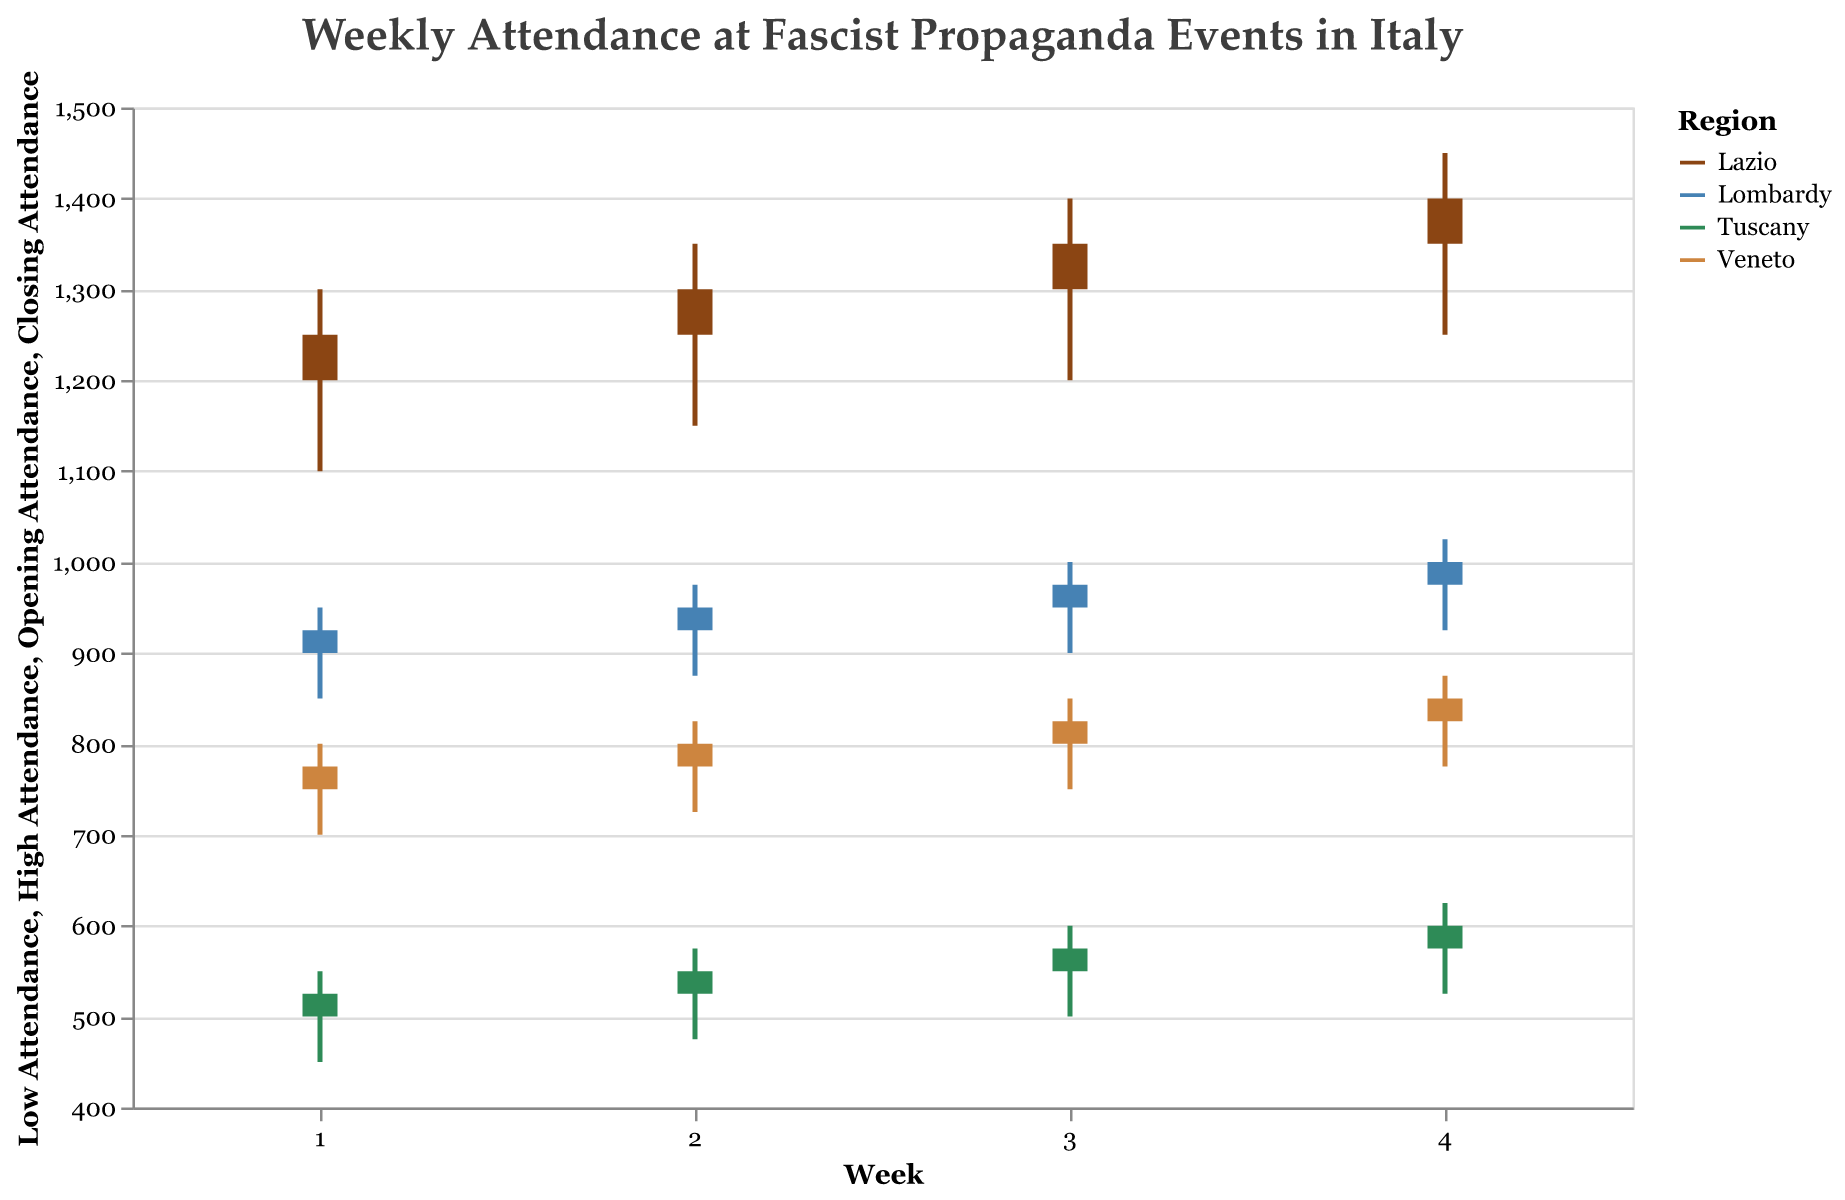What is the title of the figure? The title is usually displayed at the top of the figure and indicates the overall subject or data being presented.
Answer: Weekly Attendance at Fascist Propaganda Events in Italy Which region had the highest closing attendance in Week 4? Look for the closing attendance values for Week 4 across all regions and identify the highest one. For Week 4, closing attendance values are Lazio: 1400, Lombardy: 1000, Tuscany: 600, and Veneto: 850.
Answer: Lazio Across all regions, which week showed the most improvement in attendance from Opening to Closing? Calculate the difference between Opening and Closing attendance for each week and compare them.
Answer: Week 4 for Lazio (1400 - 1350 = 50) Identify the region with the least variability in attendance during Week 2. Variability can be understood by the range (High Attendance - Low Attendance). For Week 2, the ranges are Lazio: 1350 - 1150 = 200, Lombardy: 975 - 875 = 100, Tuscany: 575 - 475 = 100, Veneto: 825 - 725 = 100.
Answer: Lombardy, Tuscany, or Veneto Which region showed the most consistent week-to-week increase in attendance? Check if the increase (difference between closing attendance of consecutive weeks) is consistent for any region. Lazio shows a consistent increase from 1250, 1300, 1350, to 1400.
Answer: Lazio Between Lombardy and Veneto, which region had a higher average closing attendance over the 4 weeks? Add the closing attendance values for Lombardy and Veneto over the 4 weeks and divide by 4. Lombardy: (925 + 950 + 975 + 1000) / 4 = 962.5, Veneto: (775 + 800 + 825 + 850) / 4 = 812.5.
Answer: Lombardy How does the attendance range (High - Low) for Lazio in Week 3 compare to Tuscany in Week 3? Calculate the range for each region in Week 3 and compare them. Lazio: 1400 - 1200 = 200, Tuscany: 600 - 500 = 100.
Answer: Lazio's range is larger In which week did Veneto see the highest high attendance value? Identify the maximum high attendance values for Veneto over the weeks. It is 875 in Week 4.
Answer: Week 4 What is the total closing attendance for all regions in Week 1? Sum up the closing attendance values for each region in Week 1. 1250 (Lazio) + 925 (Lombardy) + 525 (Tuscany) + 775 (Veneto) = 3475.
Answer: 3475 